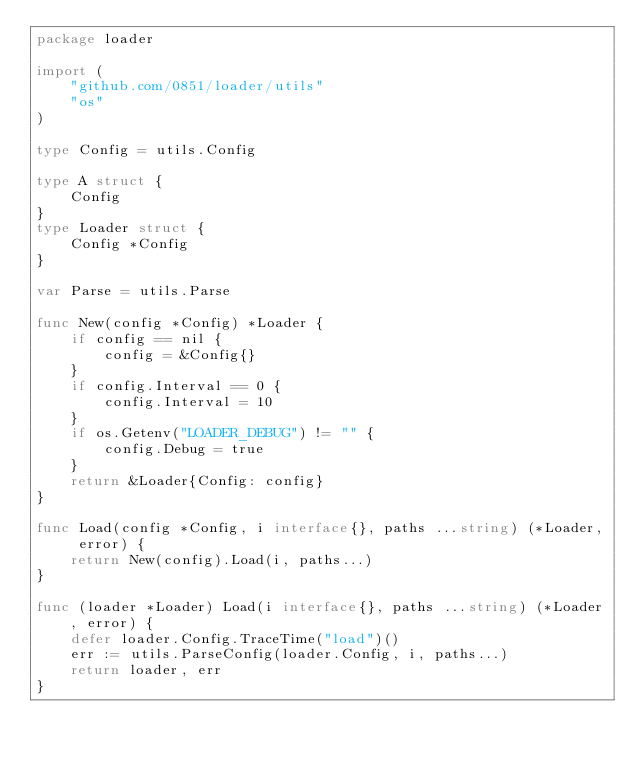<code> <loc_0><loc_0><loc_500><loc_500><_Go_>package loader

import (
	"github.com/0851/loader/utils"
	"os"
)

type Config = utils.Config

type A struct {
	Config
}
type Loader struct {
	Config *Config
}

var Parse = utils.Parse

func New(config *Config) *Loader {
	if config == nil {
		config = &Config{}
	}
	if config.Interval == 0 {
		config.Interval = 10
	}
	if os.Getenv("LOADER_DEBUG") != "" {
		config.Debug = true
	}
	return &Loader{Config: config}
}

func Load(config *Config, i interface{}, paths ...string) (*Loader, error) {
	return New(config).Load(i, paths...)
}

func (loader *Loader) Load(i interface{}, paths ...string) (*Loader, error) {
	defer loader.Config.TraceTime("load")()
	err := utils.ParseConfig(loader.Config, i, paths...)
	return loader, err
}
</code> 